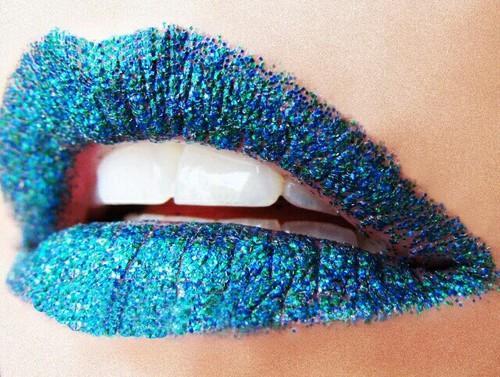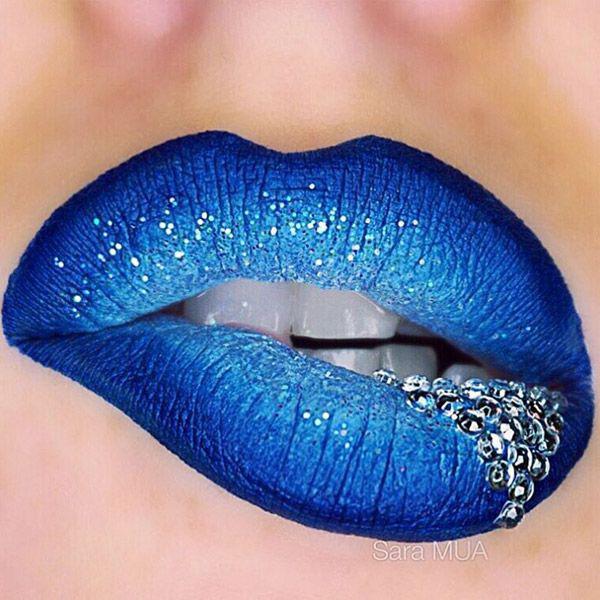The first image is the image on the left, the second image is the image on the right. Considering the images on both sides, is "A single rhinestone stud is directly above a pair of glittery lips in one image." valid? Answer yes or no. No. The first image is the image on the left, the second image is the image on the right. Analyze the images presented: Is the assertion "One of the lips has a piercing directly above the upper lip that is not attached to the nose." valid? Answer yes or no. No. 